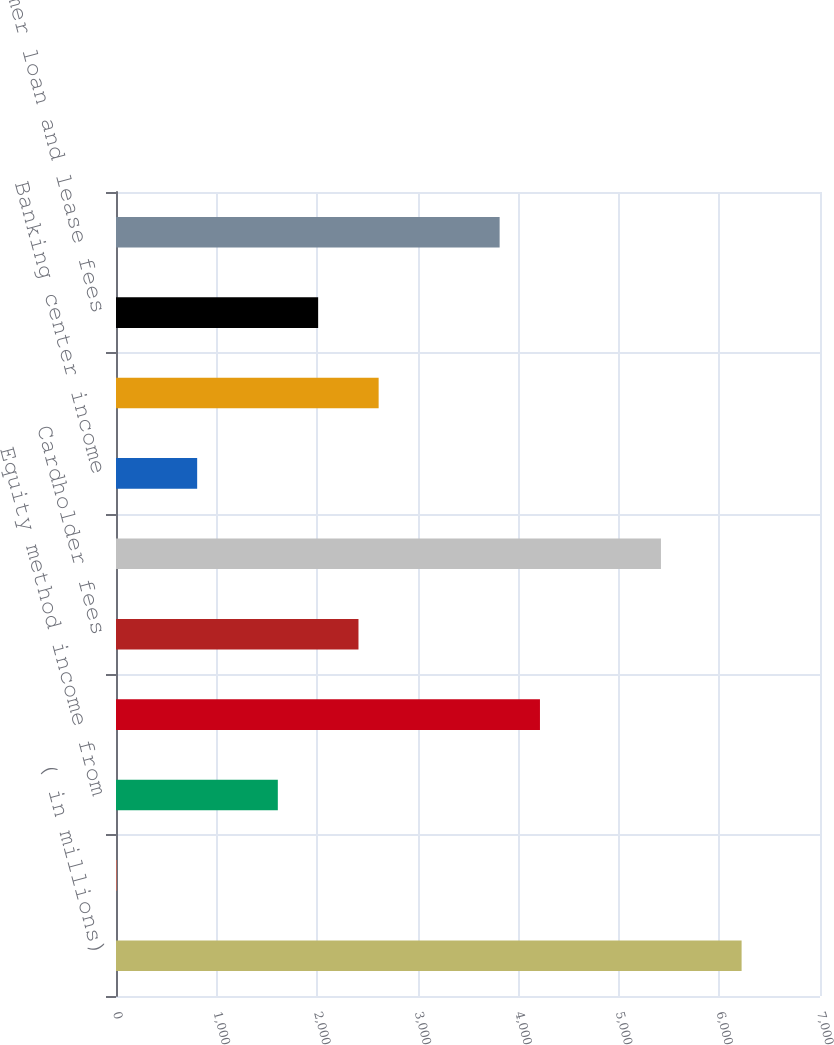<chart> <loc_0><loc_0><loc_500><loc_500><bar_chart><fcel>( in millions)<fcel>Net gain from warrant and put<fcel>Equity method income from<fcel>Operating lease income<fcel>Cardholder fees<fcel>BOLI income<fcel>Banking center income<fcel>Insurance income<fcel>Consumer loan and lease fees<fcel>Gain on loan sales<nl><fcel>6220.5<fcel>5<fcel>1609<fcel>4215.5<fcel>2411<fcel>5418.5<fcel>807<fcel>2611.5<fcel>2010<fcel>3814.5<nl></chart> 